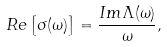<formula> <loc_0><loc_0><loc_500><loc_500>R e \left [ \sigma ( \omega ) \right ] = \frac { I m \Lambda ( \omega ) } { \omega } ,</formula> 